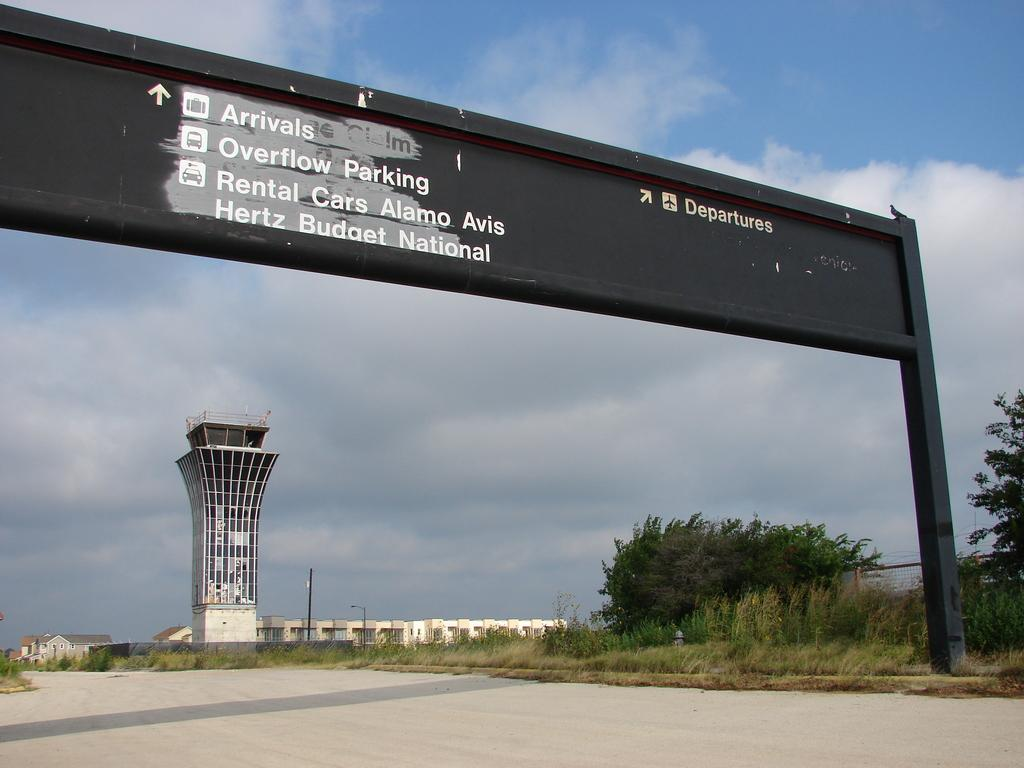Provide a one-sentence caption for the provided image. An overhead airport sign is in front of a building. 